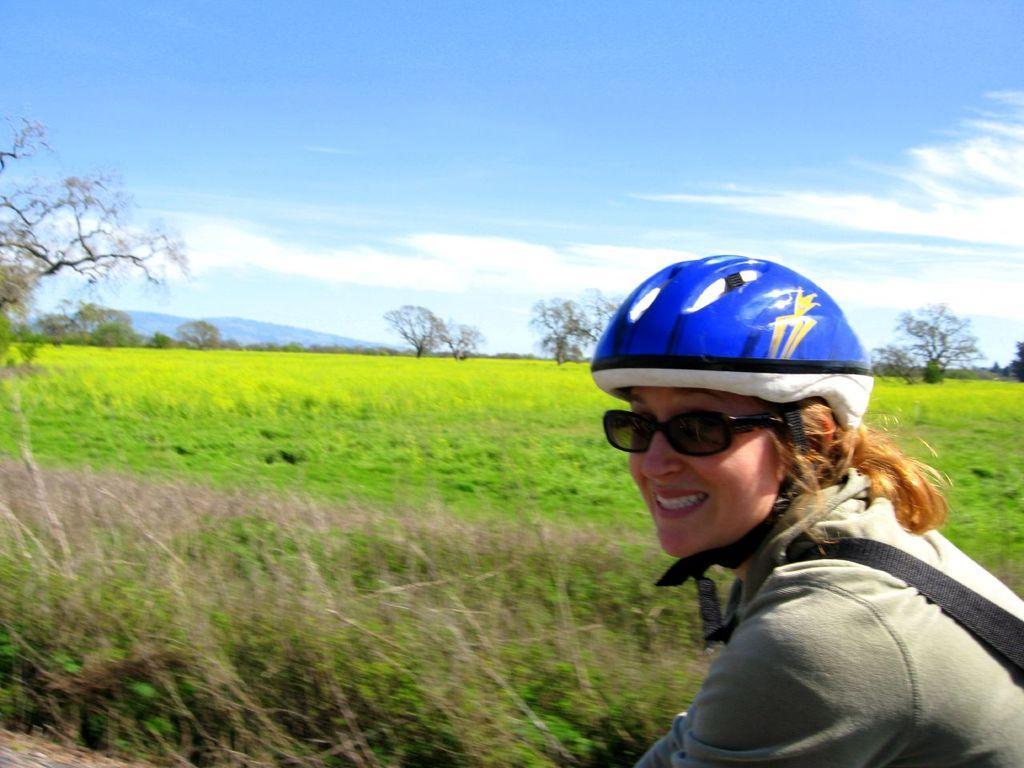How would you summarize this image in a sentence or two? This image is taken outdoors. At the top of the image there is a sky with clouds. At the bottom of the image there is a ground with grass and plants on it. In the background there are a few trees and hills. On the right side of the image there is a woman with a smiling face and she has worn a helmet. 